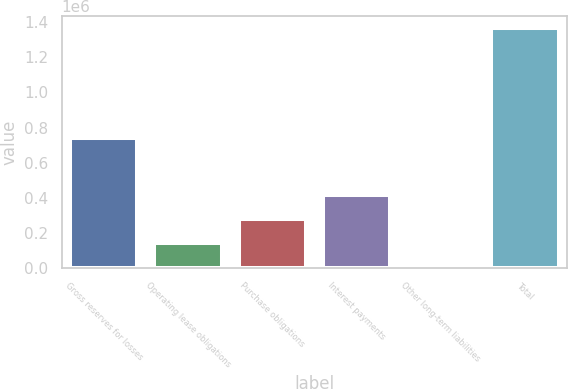<chart> <loc_0><loc_0><loc_500><loc_500><bar_chart><fcel>Gross reserves for losses<fcel>Operating lease obligations<fcel>Purchase obligations<fcel>Interest payments<fcel>Other long-term liabilities<fcel>Total<nl><fcel>739210<fcel>139921<fcel>276205<fcel>412488<fcel>3637<fcel>1.36648e+06<nl></chart> 